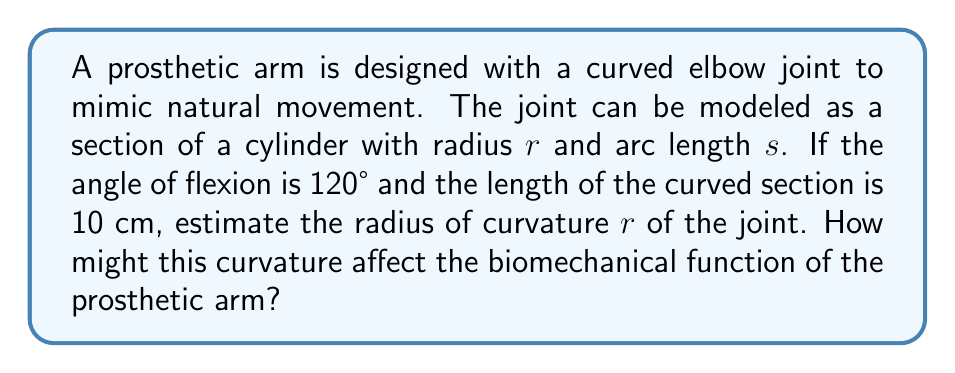Teach me how to tackle this problem. To solve this problem, we'll use the formula for arc length of a circular sector:

$$s = r\theta$$

Where:
$s$ = arc length
$r$ = radius of curvature
$\theta$ = angle in radians

Step 1: Convert the angle from degrees to radians
120° = $\frac{120 \pi}{180} = \frac{2\pi}{3}$ radians

Step 2: Substitute the known values into the arc length formula
$10 = r \cdot \frac{2\pi}{3}$

Step 3: Solve for $r$
$$r = \frac{10}{\frac{2\pi}{3}} = \frac{30}{2\pi} \approx 4.77 \text{ cm}$$

The radius of curvature is approximately 4.77 cm.

Biomechanical implications:
1. A smaller radius of curvature (tighter curve) may allow for a more compact design but could increase stress on the joint.
2. A larger radius of curvature may provide smoother motion and better load distribution but could make the prosthetic bulkier.
3. The optimal curvature should balance natural movement, stress distribution, and overall prosthetic size to maximize function and comfort for the patient.
Answer: $r \approx 4.77 \text{ cm}$ 